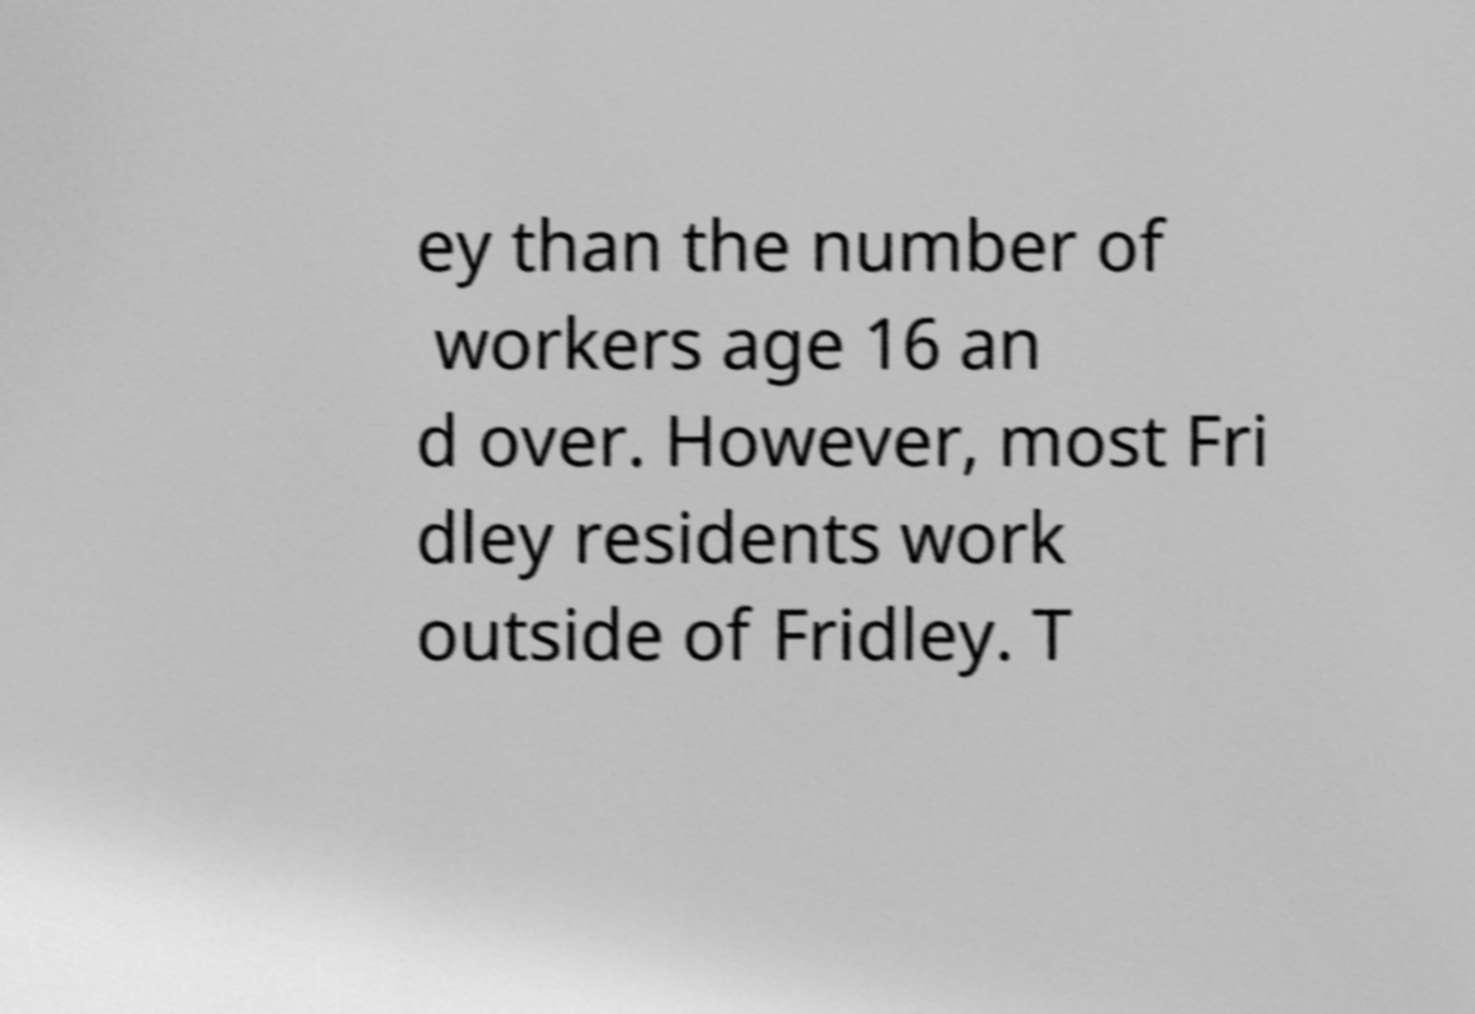There's text embedded in this image that I need extracted. Can you transcribe it verbatim? ey than the number of workers age 16 an d over. However, most Fri dley residents work outside of Fridley. T 